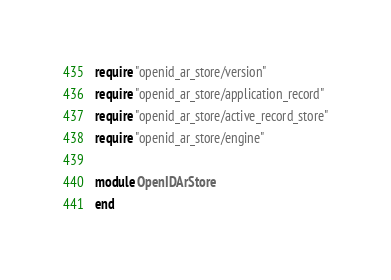<code> <loc_0><loc_0><loc_500><loc_500><_Ruby_>require "openid_ar_store/version"
require "openid_ar_store/application_record"
require "openid_ar_store/active_record_store"
require "openid_ar_store/engine"

module OpenIDArStore
end
</code> 